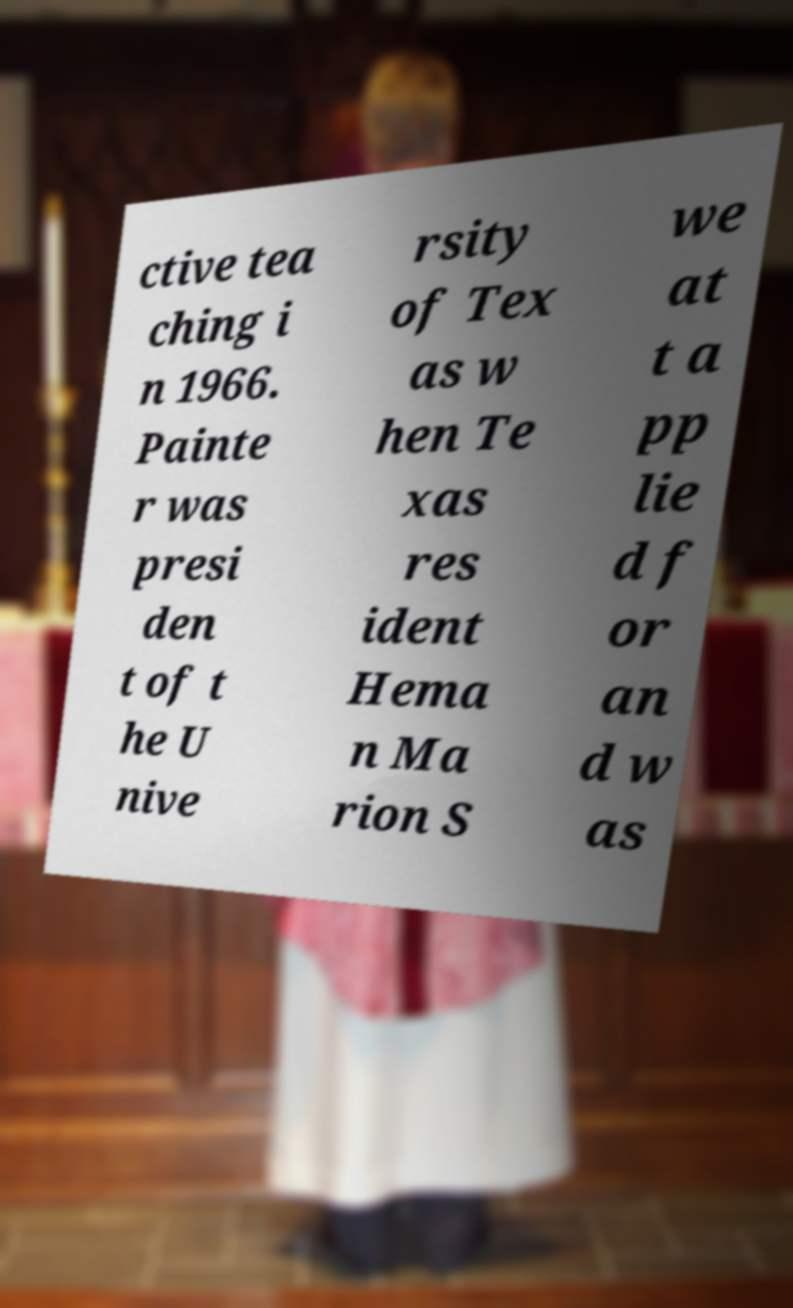Could you extract and type out the text from this image? ctive tea ching i n 1966. Painte r was presi den t of t he U nive rsity of Tex as w hen Te xas res ident Hema n Ma rion S we at t a pp lie d f or an d w as 